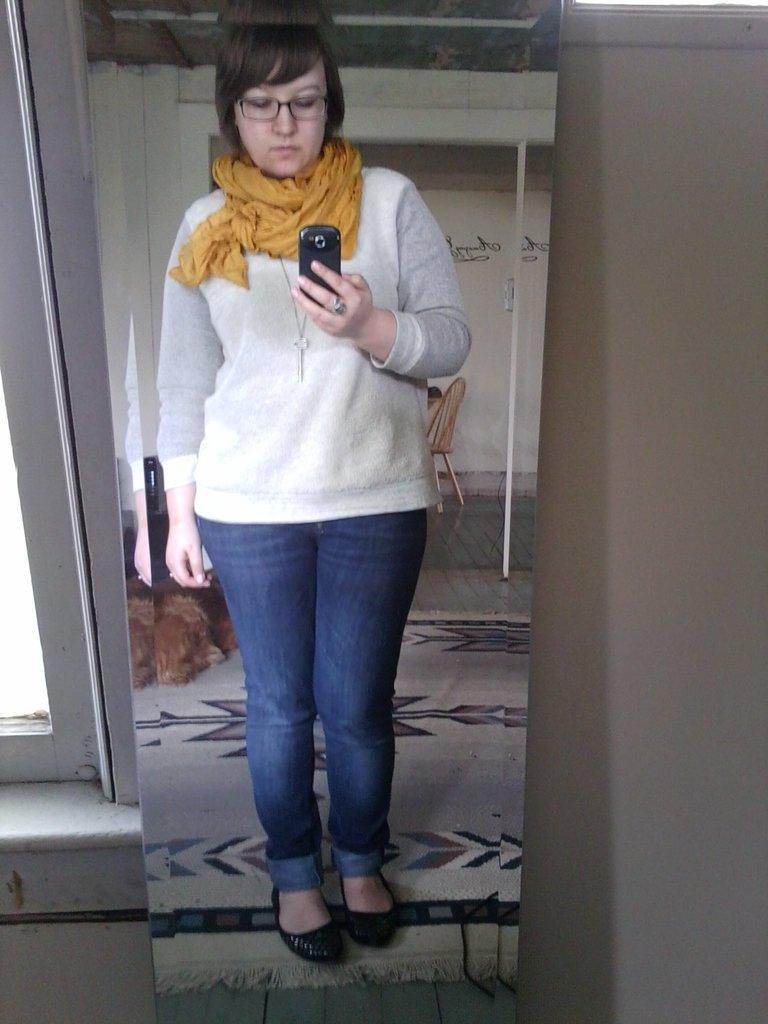Who is present in the image? There is a woman in the image. What is the woman doing in the image? The woman is standing on the floor and holding a mobile in her hand. What can be seen in the background of the image? There is a wall in the background of the image. What architectural feature is visible on the left side of the image? There is a window on the left side of the image. Can the woman's reflection be seen in the image? Yes, the woman's reflection is visible on a mirror. What type of sticks can be seen in the woman's hair in the image? There are no sticks visible in the woman's hair in the image. What is the range of the mobile that the woman is holding in the image? The range of the mobile cannot be determined from the image, as it is not a device that emits signals or has a range. 